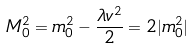<formula> <loc_0><loc_0><loc_500><loc_500>M ^ { 2 } _ { 0 } = m ^ { 2 } _ { 0 } - \frac { \lambda v ^ { 2 } } { 2 } = { 2 | m ^ { 2 } _ { 0 } | }</formula> 